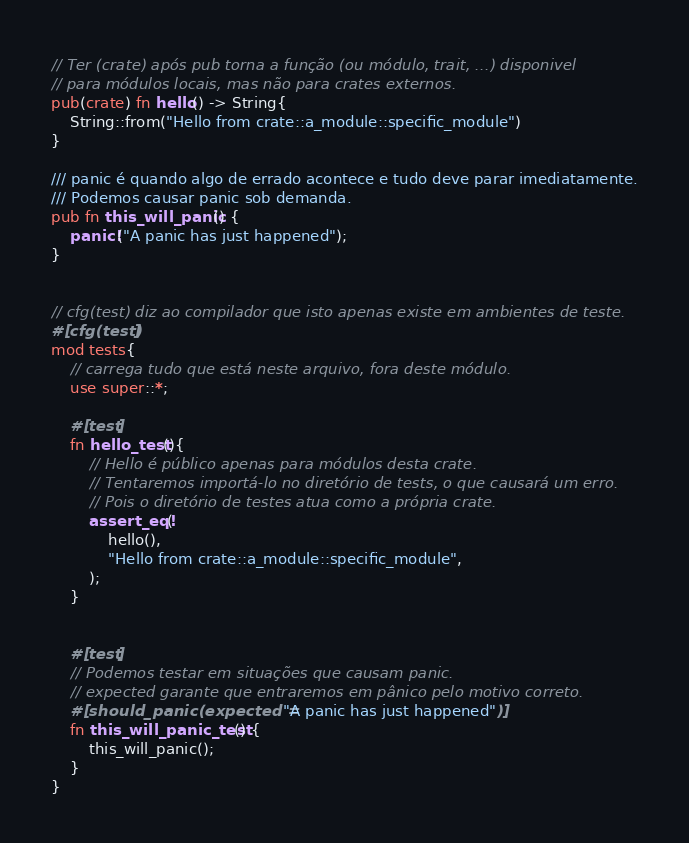<code> <loc_0><loc_0><loc_500><loc_500><_Rust_>// Ter (crate) após pub torna a função (ou módulo, trait, ...) disponivel 
// para módulos locais, mas não para crates externos.
pub(crate) fn hello() -> String{
    String::from("Hello from crate::a_module::specific_module")
}

/// panic é quando algo de errado acontece e tudo deve parar imediatamente.
/// Podemos causar panic sob demanda.
pub fn this_will_panic() {
    panic!("A panic has just happened");
}


// cfg(test) diz ao compilador que isto apenas existe em ambientes de teste.
#[cfg(test)]
mod tests{
    // carrega tudo que está neste arquivo, fora deste módulo.
    use super::*;

    #[test]
    fn hello_test(){
        // Hello é público apenas para módulos desta crate.
        // Tentaremos importá-lo no diretório de tests, o que causará um erro.
        // Pois o diretório de testes atua como a própria crate.
        assert_eq!(
            hello(),
            "Hello from crate::a_module::specific_module",
        );
    }


    #[test]
    // Podemos testar em situações que causam panic.
    // expected garante que entraremos em pânico pelo motivo correto.
    #[should_panic(expected = "A panic has just happened")]
    fn this_will_panic_test() {
        this_will_panic();
    }
}</code> 